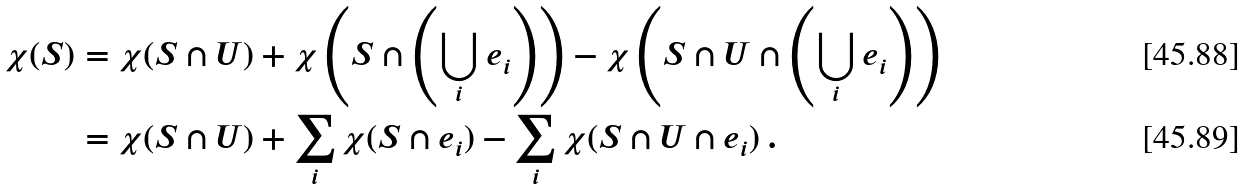<formula> <loc_0><loc_0><loc_500><loc_500>\chi ( S ) & = \chi ( S \cap U ) + \chi \left ( S \cap \left ( \bigcup _ { i } e _ { i } \right ) \right ) - \chi \left ( S \cap U \cap \left ( \bigcup _ { i } e _ { i } \right ) \right ) \\ & = \chi ( S \cap U ) + \sum _ { i } \chi ( S \cap e _ { i } ) - \sum _ { i } \chi ( S \cap U \cap e _ { i } ) \ .</formula> 